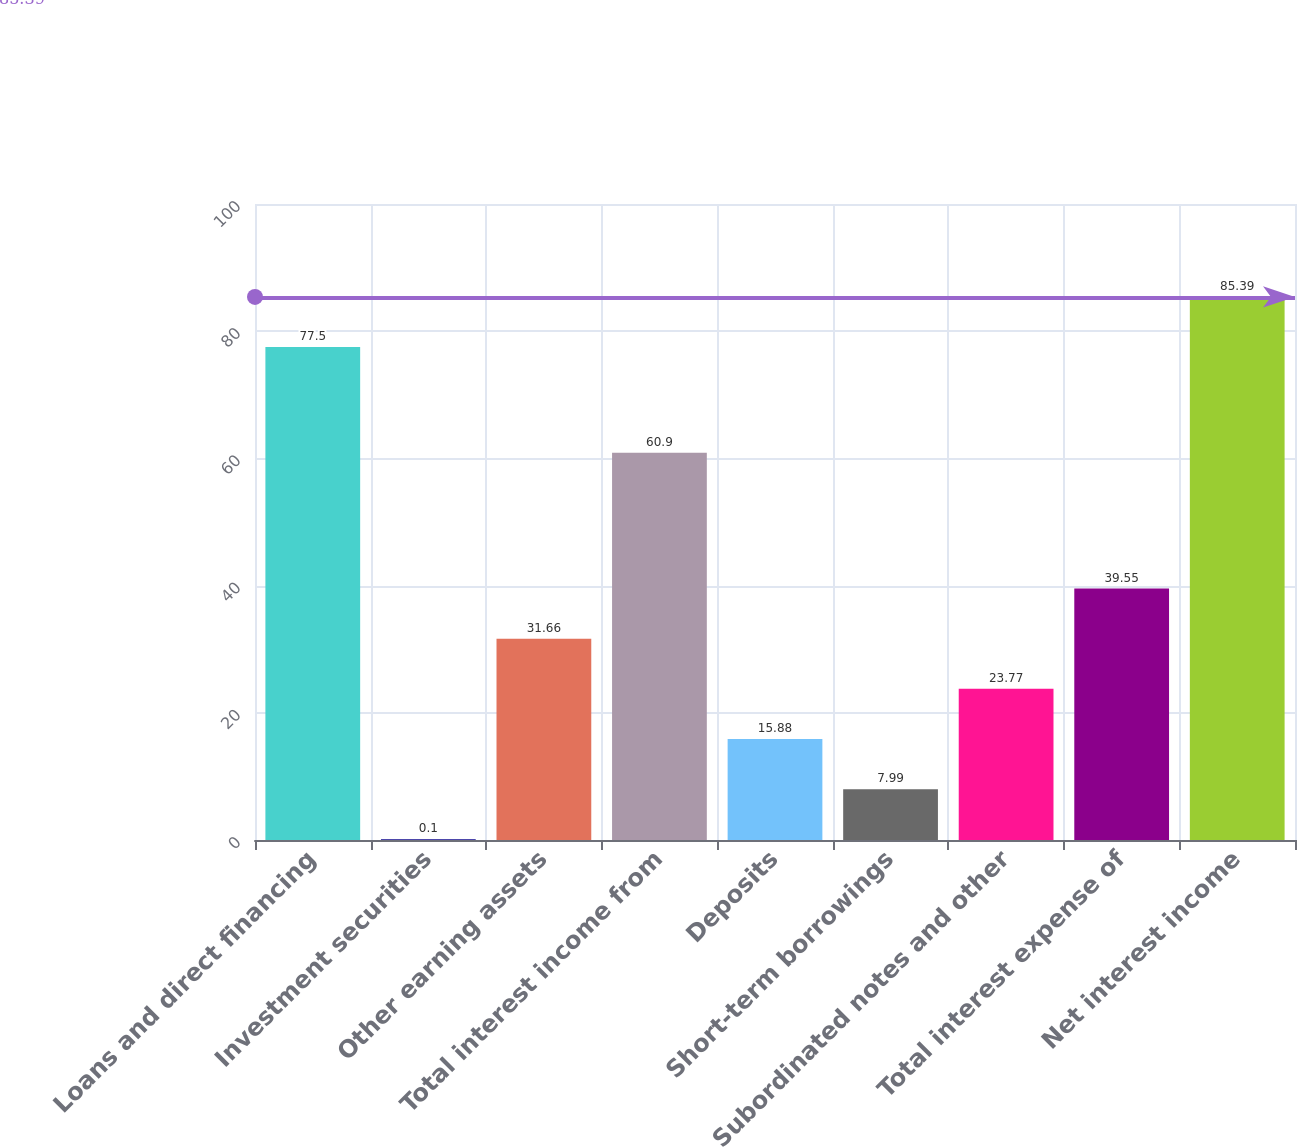Convert chart to OTSL. <chart><loc_0><loc_0><loc_500><loc_500><bar_chart><fcel>Loans and direct financing<fcel>Investment securities<fcel>Other earning assets<fcel>Total interest income from<fcel>Deposits<fcel>Short-term borrowings<fcel>Subordinated notes and other<fcel>Total interest expense of<fcel>Net interest income<nl><fcel>77.5<fcel>0.1<fcel>31.66<fcel>60.9<fcel>15.88<fcel>7.99<fcel>23.77<fcel>39.55<fcel>85.39<nl></chart> 